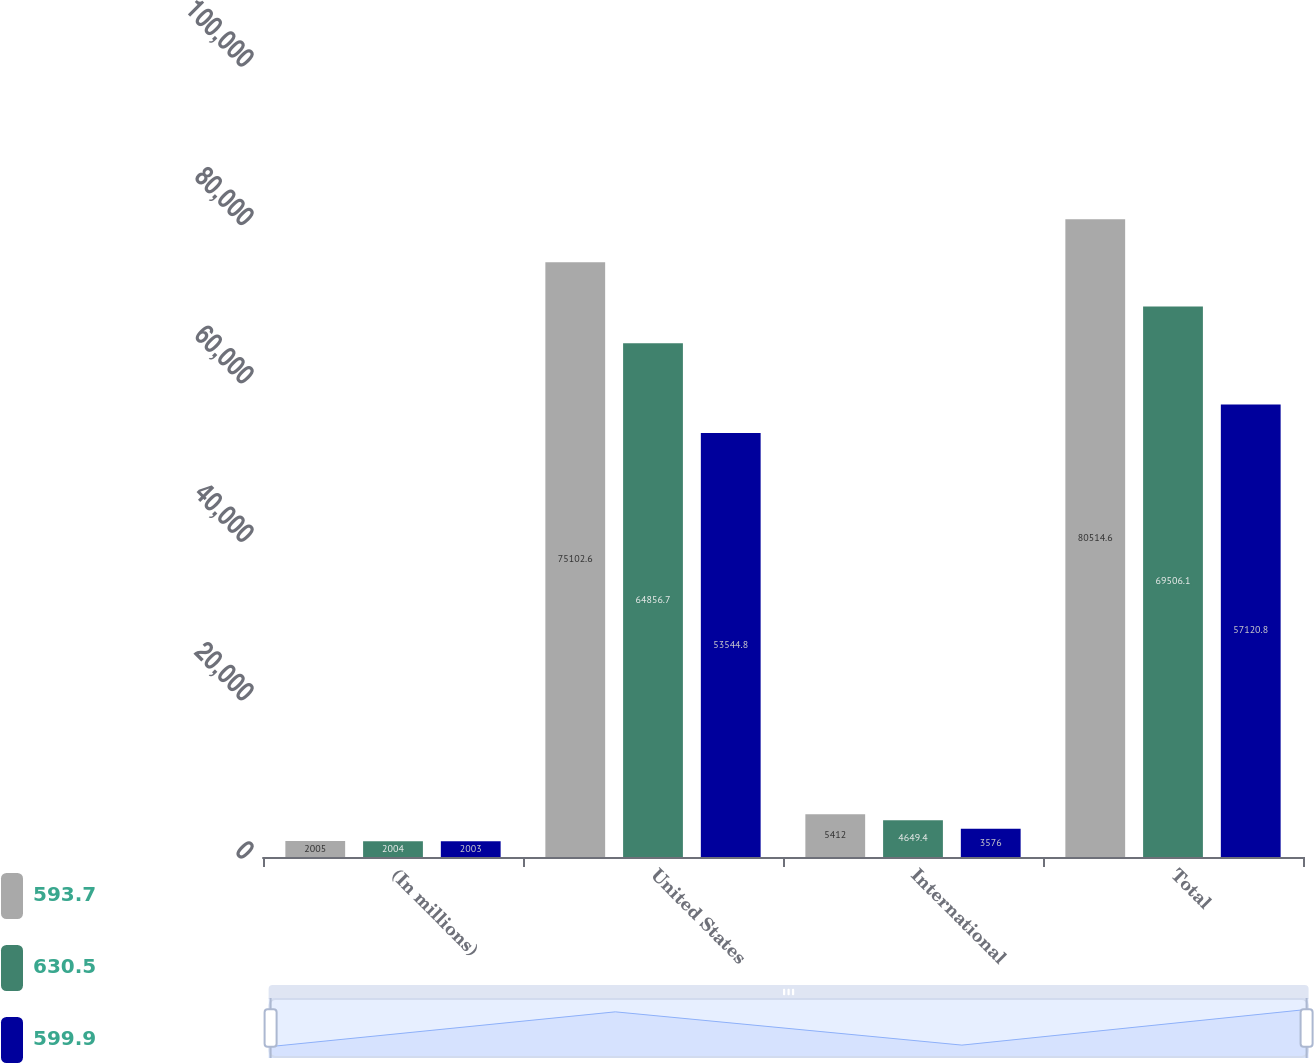Convert chart to OTSL. <chart><loc_0><loc_0><loc_500><loc_500><stacked_bar_chart><ecel><fcel>(In millions)<fcel>United States<fcel>International<fcel>Total<nl><fcel>593.7<fcel>2005<fcel>75102.6<fcel>5412<fcel>80514.6<nl><fcel>630.5<fcel>2004<fcel>64856.7<fcel>4649.4<fcel>69506.1<nl><fcel>599.9<fcel>2003<fcel>53544.8<fcel>3576<fcel>57120.8<nl></chart> 